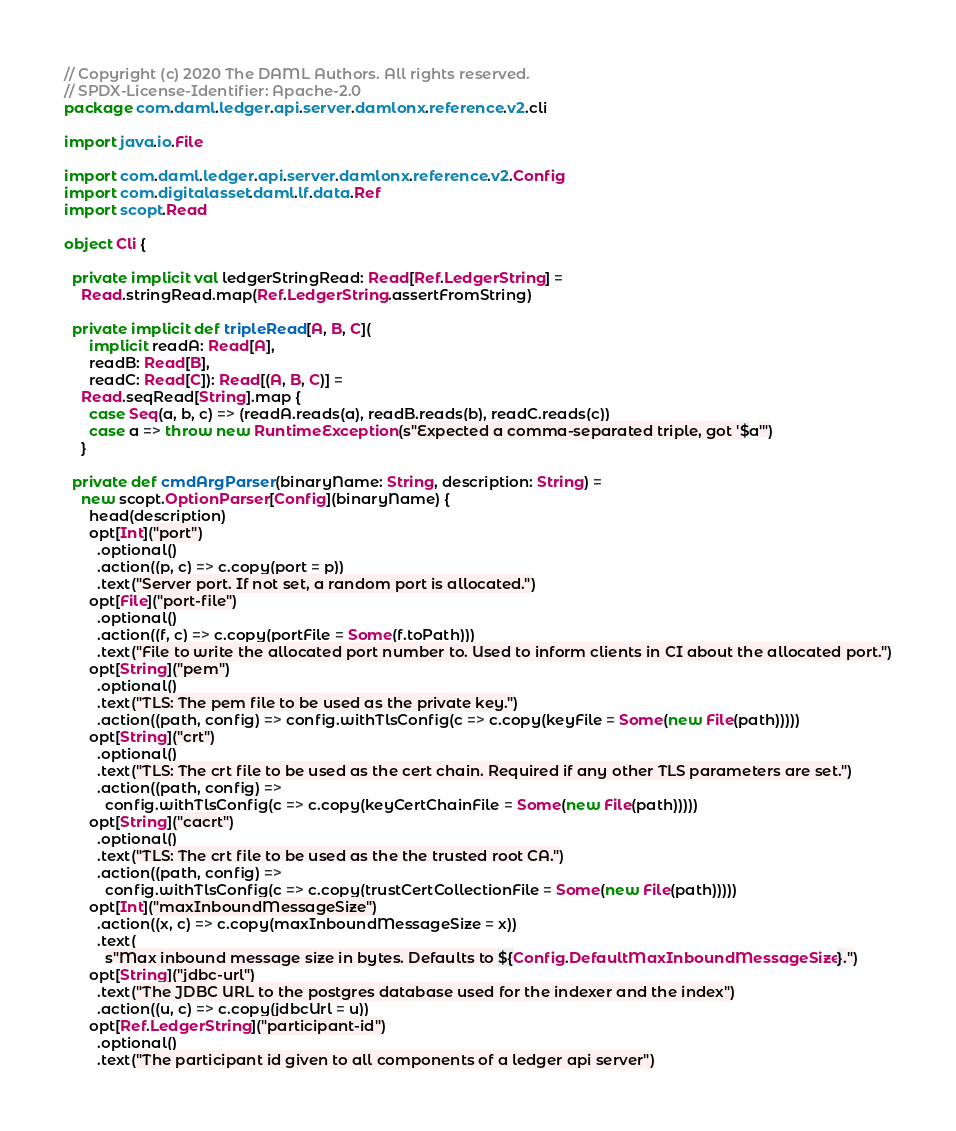Convert code to text. <code><loc_0><loc_0><loc_500><loc_500><_Scala_>// Copyright (c) 2020 The DAML Authors. All rights reserved.
// SPDX-License-Identifier: Apache-2.0
package com.daml.ledger.api.server.damlonx.reference.v2.cli

import java.io.File

import com.daml.ledger.api.server.damlonx.reference.v2.Config
import com.digitalasset.daml.lf.data.Ref
import scopt.Read

object Cli {

  private implicit val ledgerStringRead: Read[Ref.LedgerString] =
    Read.stringRead.map(Ref.LedgerString.assertFromString)

  private implicit def tripleRead[A, B, C](
      implicit readA: Read[A],
      readB: Read[B],
      readC: Read[C]): Read[(A, B, C)] =
    Read.seqRead[String].map {
      case Seq(a, b, c) => (readA.reads(a), readB.reads(b), readC.reads(c))
      case a => throw new RuntimeException(s"Expected a comma-separated triple, got '$a'")
    }

  private def cmdArgParser(binaryName: String, description: String) =
    new scopt.OptionParser[Config](binaryName) {
      head(description)
      opt[Int]("port")
        .optional()
        .action((p, c) => c.copy(port = p))
        .text("Server port. If not set, a random port is allocated.")
      opt[File]("port-file")
        .optional()
        .action((f, c) => c.copy(portFile = Some(f.toPath)))
        .text("File to write the allocated port number to. Used to inform clients in CI about the allocated port.")
      opt[String]("pem")
        .optional()
        .text("TLS: The pem file to be used as the private key.")
        .action((path, config) => config.withTlsConfig(c => c.copy(keyFile = Some(new File(path)))))
      opt[String]("crt")
        .optional()
        .text("TLS: The crt file to be used as the cert chain. Required if any other TLS parameters are set.")
        .action((path, config) =>
          config.withTlsConfig(c => c.copy(keyCertChainFile = Some(new File(path)))))
      opt[String]("cacrt")
        .optional()
        .text("TLS: The crt file to be used as the the trusted root CA.")
        .action((path, config) =>
          config.withTlsConfig(c => c.copy(trustCertCollectionFile = Some(new File(path)))))
      opt[Int]("maxInboundMessageSize")
        .action((x, c) => c.copy(maxInboundMessageSize = x))
        .text(
          s"Max inbound message size in bytes. Defaults to ${Config.DefaultMaxInboundMessageSize}.")
      opt[String]("jdbc-url")
        .text("The JDBC URL to the postgres database used for the indexer and the index")
        .action((u, c) => c.copy(jdbcUrl = u))
      opt[Ref.LedgerString]("participant-id")
        .optional()
        .text("The participant id given to all components of a ledger api server")</code> 